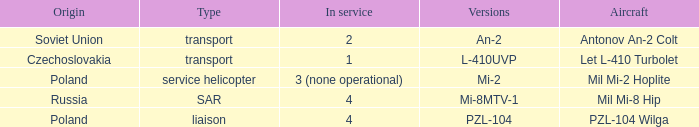Tell me the service for versions l-410uvp 1.0. 